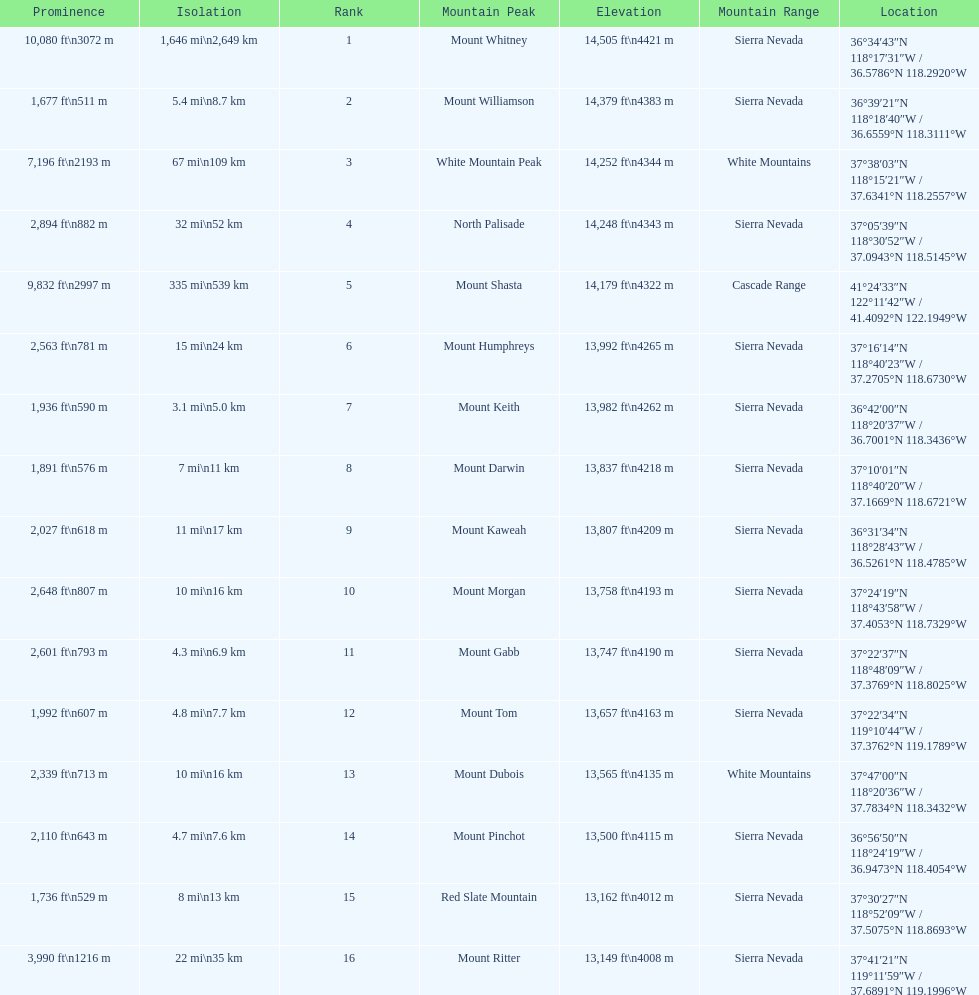How much taller is the mountain peak of mount williamson than that of mount keith? 397 ft. 